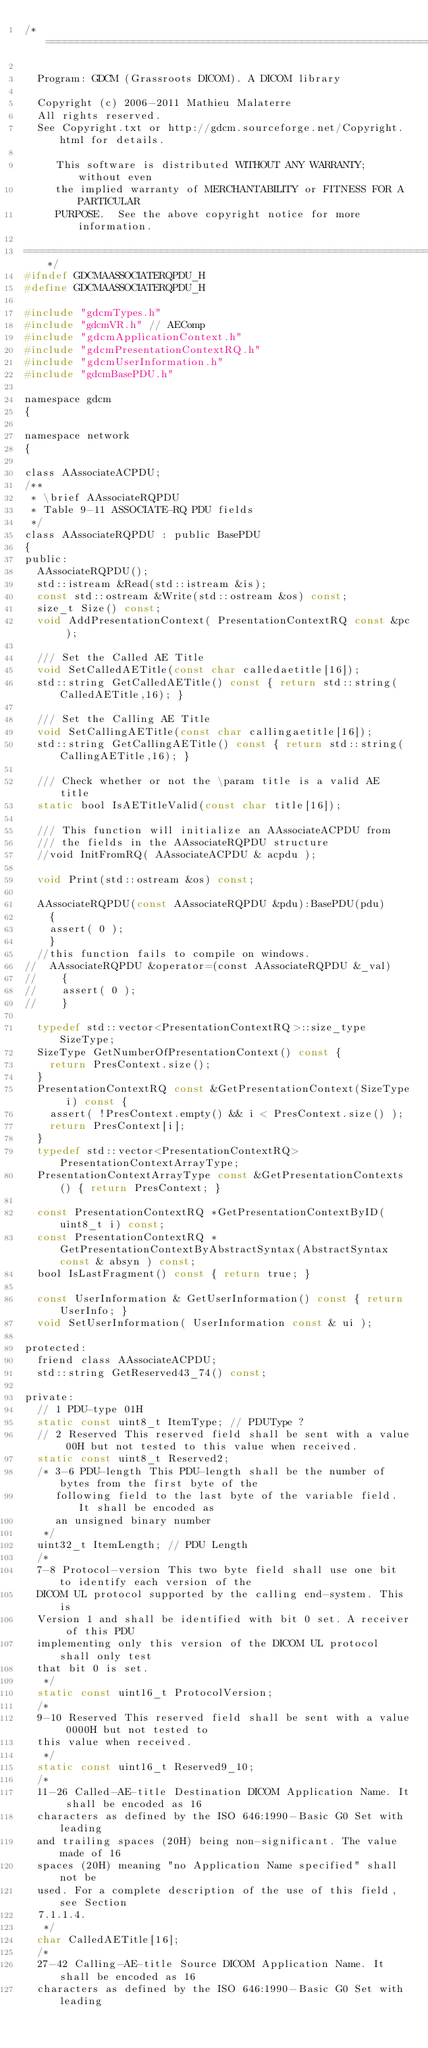Convert code to text. <code><loc_0><loc_0><loc_500><loc_500><_C_>/*=========================================================================

  Program: GDCM (Grassroots DICOM). A DICOM library

  Copyright (c) 2006-2011 Mathieu Malaterre
  All rights reserved.
  See Copyright.txt or http://gdcm.sourceforge.net/Copyright.html for details.

     This software is distributed WITHOUT ANY WARRANTY; without even
     the implied warranty of MERCHANTABILITY or FITNESS FOR A PARTICULAR
     PURPOSE.  See the above copyright notice for more information.

=========================================================================*/
#ifndef GDCMAASSOCIATERQPDU_H
#define GDCMAASSOCIATERQPDU_H

#include "gdcmTypes.h"
#include "gdcmVR.h" // AEComp
#include "gdcmApplicationContext.h"
#include "gdcmPresentationContextRQ.h"
#include "gdcmUserInformation.h"
#include "gdcmBasePDU.h"

namespace gdcm
{

namespace network
{

class AAssociateACPDU;
/**
 * \brief AAssociateRQPDU
 * Table 9-11 ASSOCIATE-RQ PDU fields
 */
class AAssociateRQPDU : public BasePDU
{
public:
  AAssociateRQPDU();
  std::istream &Read(std::istream &is);
  const std::ostream &Write(std::ostream &os) const;
  size_t Size() const;
  void AddPresentationContext( PresentationContextRQ const &pc );

  /// Set the Called AE Title
  void SetCalledAETitle(const char calledaetitle[16]);
  std::string GetCalledAETitle() const { return std::string(CalledAETitle,16); }

  /// Set the Calling AE Title
  void SetCallingAETitle(const char callingaetitle[16]);
  std::string GetCallingAETitle() const { return std::string(CallingAETitle,16); }

  /// Check whether or not the \param title is a valid AE title
  static bool IsAETitleValid(const char title[16]);

  /// This function will initialize an AAssociateACPDU from
  /// the fields in the AAssociateRQPDU structure
  //void InitFromRQ( AAssociateACPDU & acpdu );

  void Print(std::ostream &os) const;

  AAssociateRQPDU(const AAssociateRQPDU &pdu):BasePDU(pdu)
    {
    assert( 0 );
    }
  //this function fails to compile on windows.
//  AAssociateRQPDU &operator=(const AAssociateRQPDU &_val)
//    {
//    assert( 0 );
//    }

  typedef std::vector<PresentationContextRQ>::size_type SizeType;
  SizeType GetNumberOfPresentationContext() const {
    return PresContext.size();
  }
  PresentationContextRQ const &GetPresentationContext(SizeType i) const {
    assert( !PresContext.empty() && i < PresContext.size() );
    return PresContext[i];
  }
  typedef std::vector<PresentationContextRQ> PresentationContextArrayType;
  PresentationContextArrayType const &GetPresentationContexts() { return PresContext; }

  const PresentationContextRQ *GetPresentationContextByID(uint8_t i) const;
  const PresentationContextRQ *GetPresentationContextByAbstractSyntax(AbstractSyntax const & absyn ) const;
  bool IsLastFragment() const { return true; }

  const UserInformation & GetUserInformation() const { return UserInfo; }
  void SetUserInformation( UserInformation const & ui );

protected:
  friend class AAssociateACPDU;
  std::string GetReserved43_74() const;

private:
  // 1 PDU-type 01H
  static const uint8_t ItemType; // PDUType ?
  // 2 Reserved This reserved field shall be sent with a value 00H but not tested to this value when received.
  static const uint8_t Reserved2;
  /* 3-6 PDU-length This PDU-length shall be the number of bytes from the first byte of the
     following field to the last byte of the variable field. It shall be encoded as
     an unsigned binary number
   */
  uint32_t ItemLength; // PDU Length
  /*
  7-8 Protocol-version This two byte field shall use one bit to identify each version of the
  DICOM UL protocol supported by the calling end-system. This is
  Version 1 and shall be identified with bit 0 set. A receiver of this PDU
  implementing only this version of the DICOM UL protocol shall only test
  that bit 0 is set.
   */
  static const uint16_t ProtocolVersion;
  /*
  9-10 Reserved This reserved field shall be sent with a value 0000H but not tested to
  this value when received.
   */
  static const uint16_t Reserved9_10;
  /*
  11-26 Called-AE-title Destination DICOM Application Name. It shall be encoded as 16
  characters as defined by the ISO 646:1990-Basic G0 Set with leading
  and trailing spaces (20H) being non-significant. The value made of 16
  spaces (20H) meaning "no Application Name specified" shall not be
  used. For a complete description of the use of this field, see Section
  7.1.1.4.
   */
  char CalledAETitle[16];
  /*
  27-42 Calling-AE-title Source DICOM Application Name. It shall be encoded as 16
  characters as defined by the ISO 646:1990-Basic G0 Set with leading</code> 